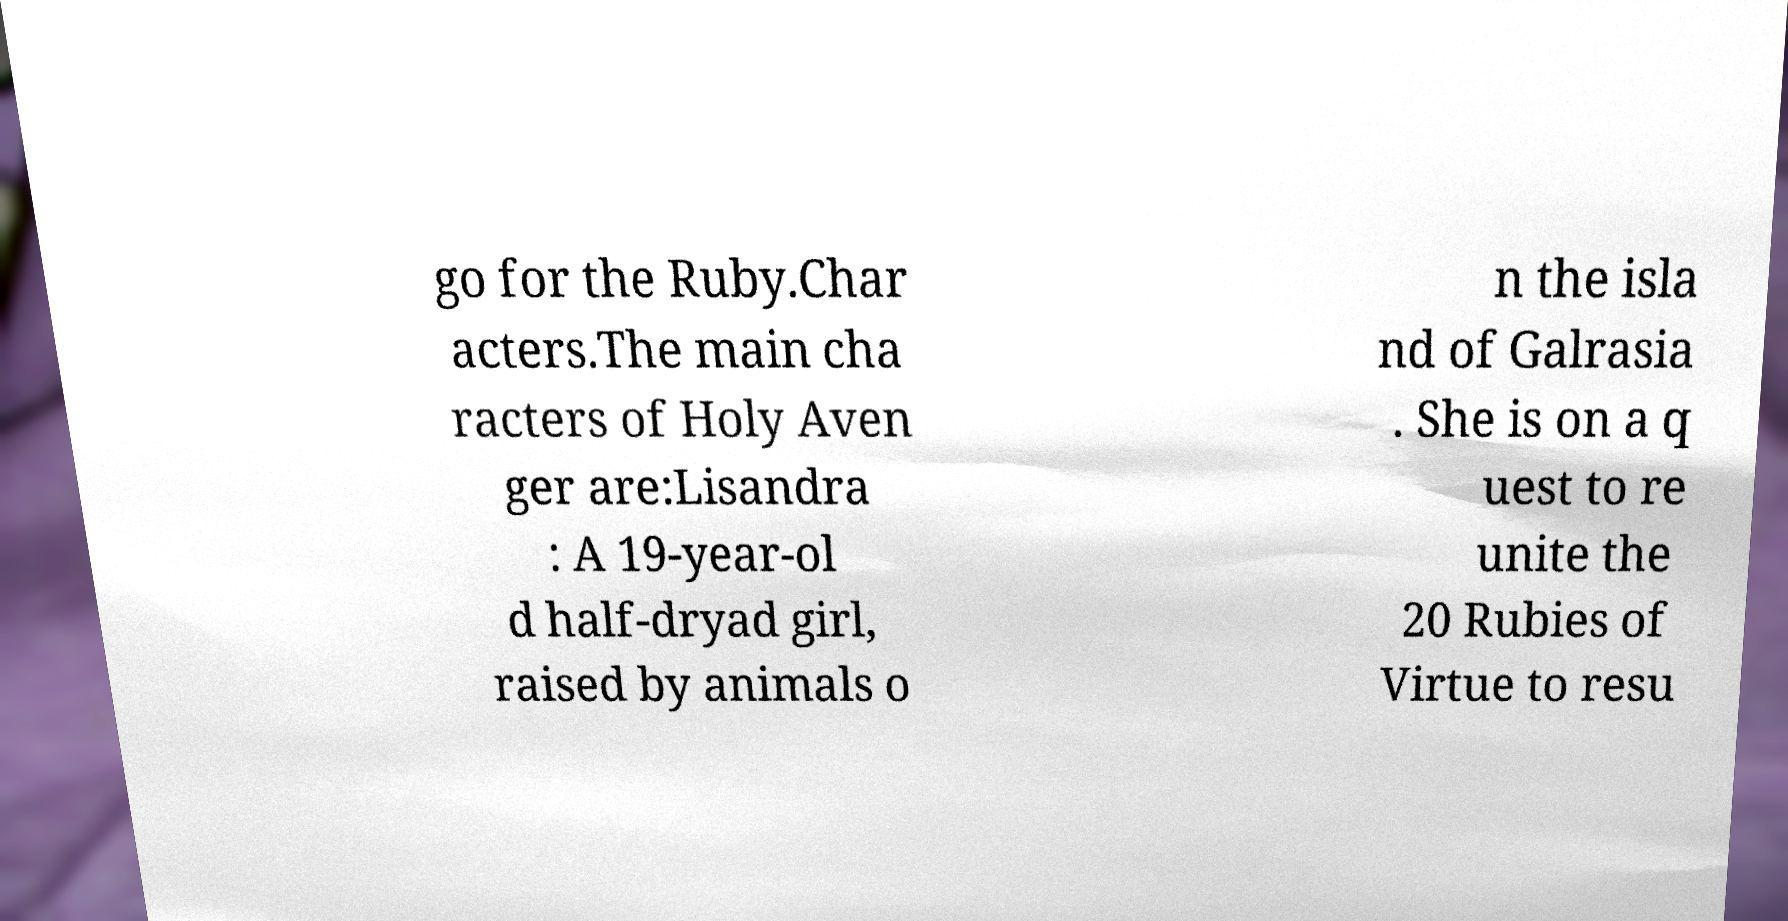I need the written content from this picture converted into text. Can you do that? go for the Ruby.Char acters.The main cha racters of Holy Aven ger are:Lisandra : A 19-year-ol d half-dryad girl, raised by animals o n the isla nd of Galrasia . She is on a q uest to re unite the 20 Rubies of Virtue to resu 